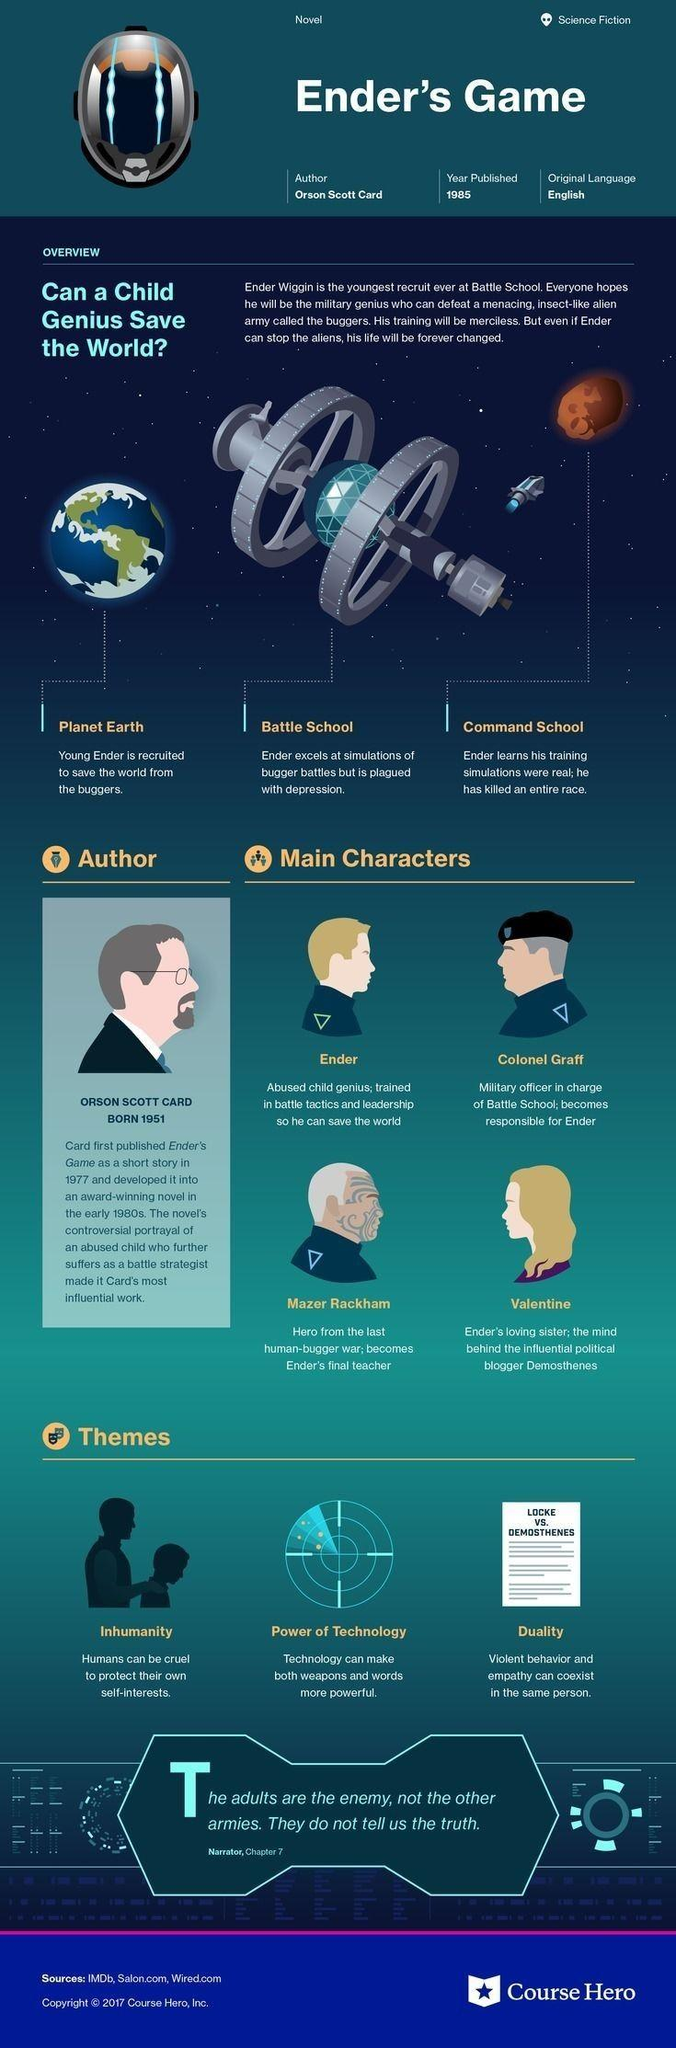Draw attention to some important aspects in this diagram. Mazer Rackham is Ender's final teacher. Orson Scott Card wrote the novel about a child genius recruited to save the earth from the buggers. Colonel Graff is responsible for Ender. I declare that the year of publication of the novel named 'Ender's Game' is 1985. There are three themes mentioned in the infographic that pertain to the novel. 